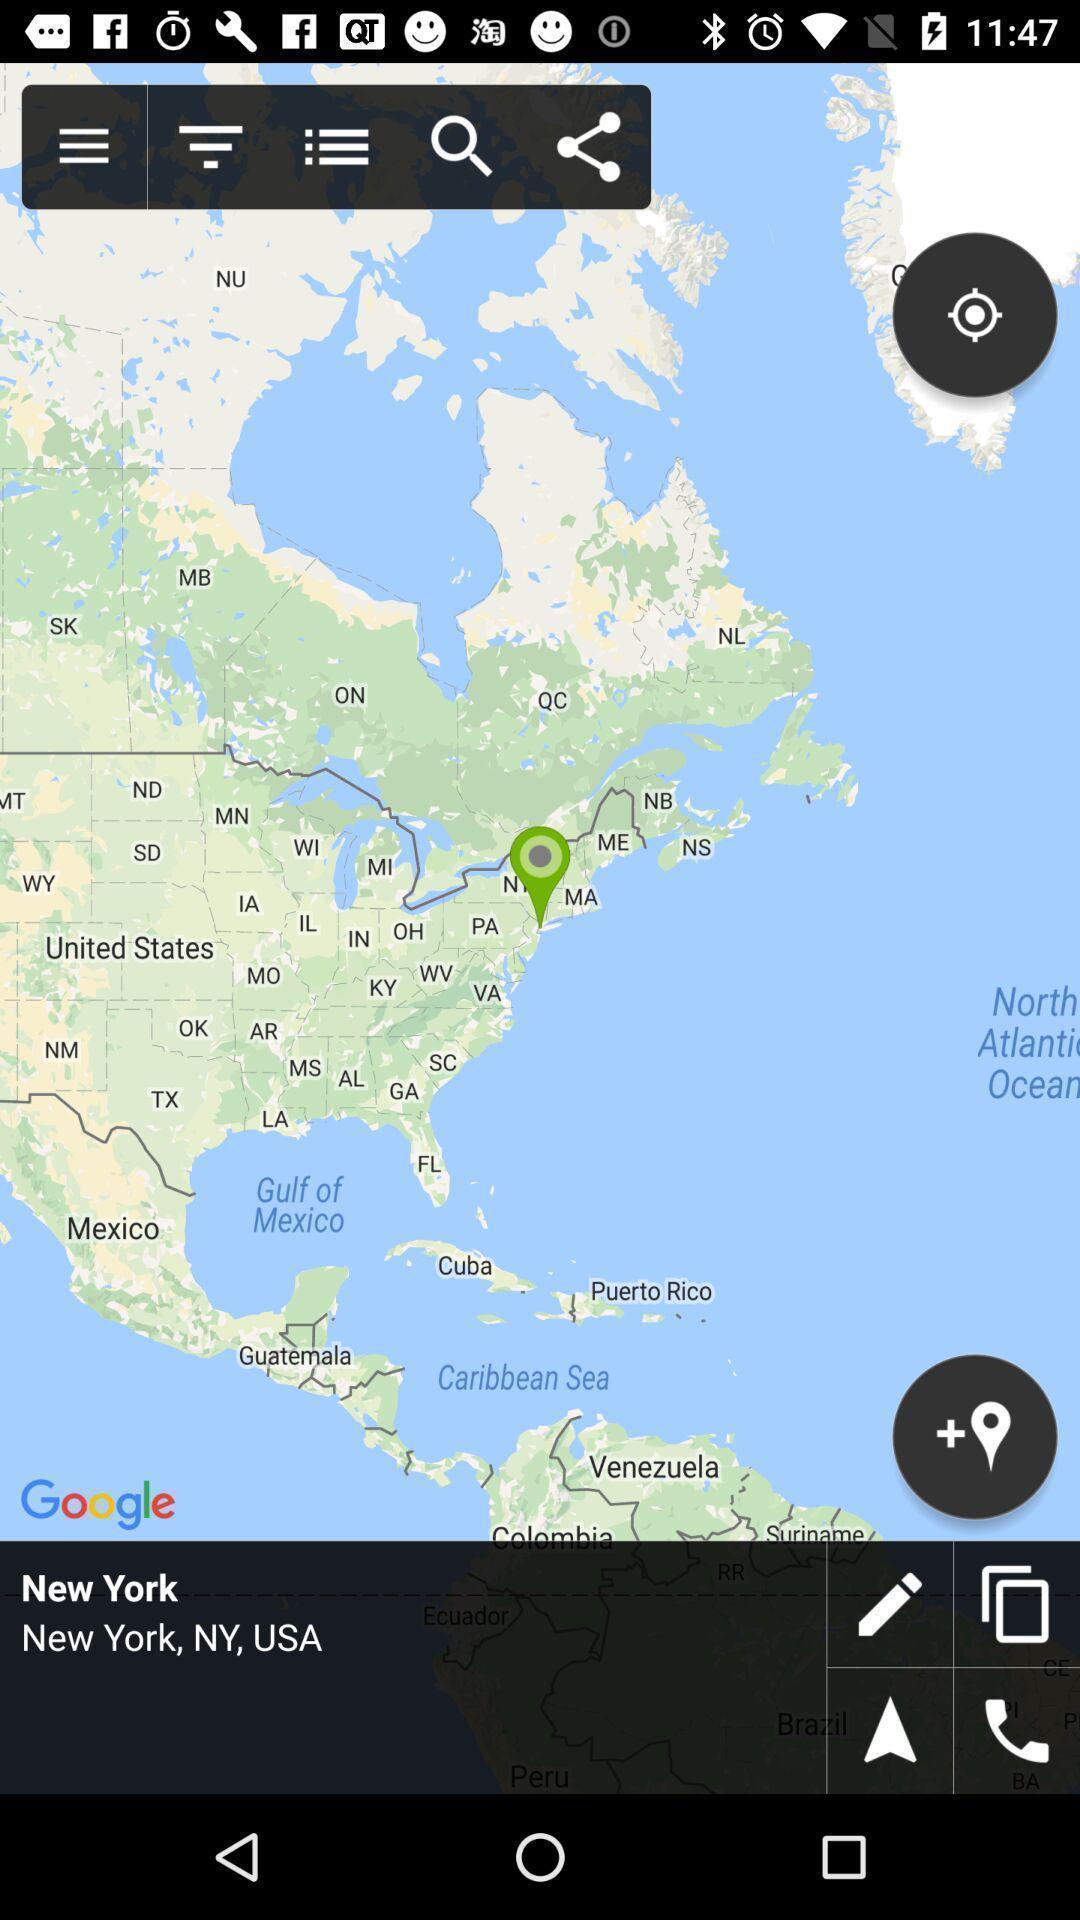Describe the key features of this screenshot. Page shows location in the map. 